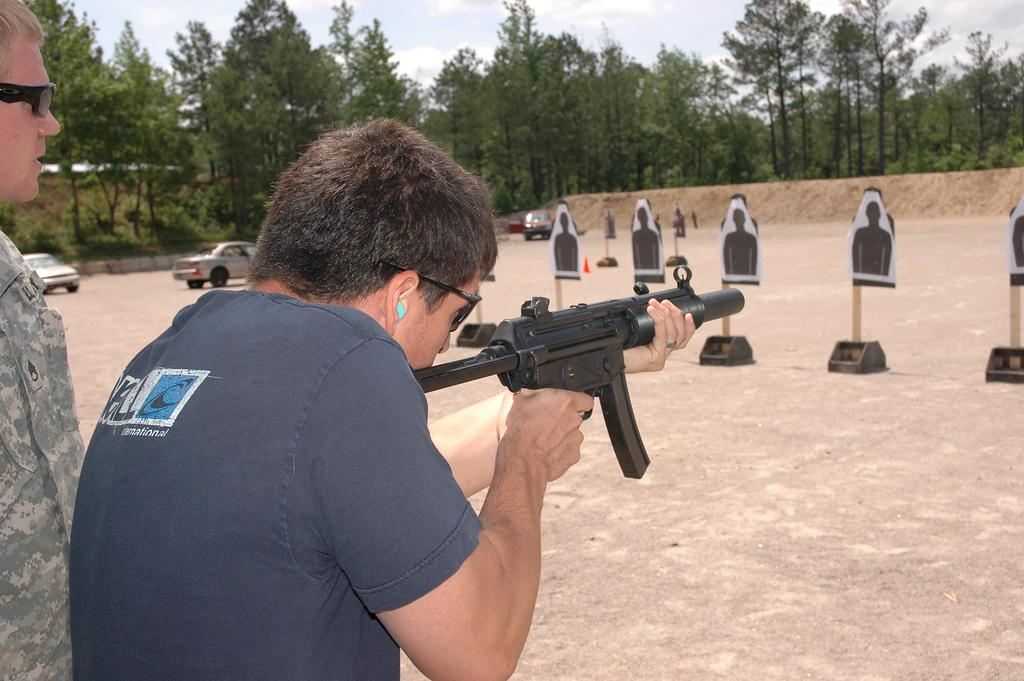What are the men in the image doing? The men in the image are standing, and one of them is holding a gun. What might the man with the gun be aiming at? There are targets on the ground, so the man with the gun might be aiming at the targets. What can be seen in the background of the image? Trees and cars are visible in the image. What is the condition of the sky in the image? The sky is cloudy in the image. How many bags can be seen hanging from the trees in the image? There are no bags visible in the image; only trees, cars, and men are present. Can you tell me where the giraffe is located in the image? There is no giraffe present in the image. 